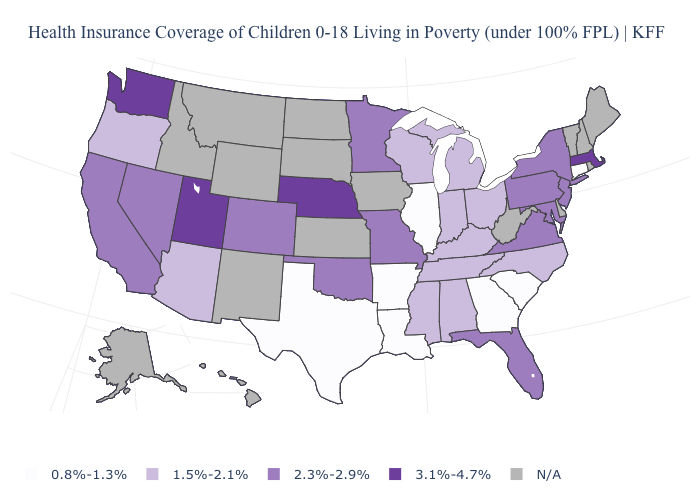What is the value of Pennsylvania?
Short answer required. 2.3%-2.9%. What is the value of New Hampshire?
Answer briefly. N/A. What is the lowest value in the USA?
Short answer required. 0.8%-1.3%. What is the value of Florida?
Answer briefly. 2.3%-2.9%. Name the states that have a value in the range 0.8%-1.3%?
Answer briefly. Arkansas, Connecticut, Georgia, Illinois, Louisiana, South Carolina, Texas. Does the map have missing data?
Give a very brief answer. Yes. What is the highest value in the MidWest ?
Concise answer only. 3.1%-4.7%. Among the states that border New Mexico , does Utah have the highest value?
Keep it brief. Yes. What is the value of California?
Short answer required. 2.3%-2.9%. What is the highest value in the USA?
Give a very brief answer. 3.1%-4.7%. Which states have the lowest value in the USA?
Short answer required. Arkansas, Connecticut, Georgia, Illinois, Louisiana, South Carolina, Texas. What is the value of Texas?
Short answer required. 0.8%-1.3%. What is the lowest value in states that border Kansas?
Answer briefly. 2.3%-2.9%. Does Nebraska have the highest value in the MidWest?
Keep it brief. Yes. 